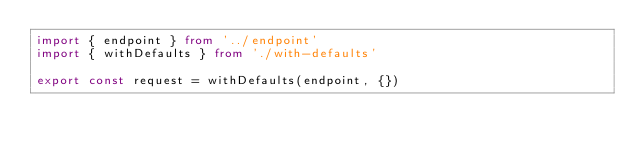<code> <loc_0><loc_0><loc_500><loc_500><_TypeScript_>import { endpoint } from '../endpoint'
import { withDefaults } from './with-defaults'

export const request = withDefaults(endpoint, {})
</code> 